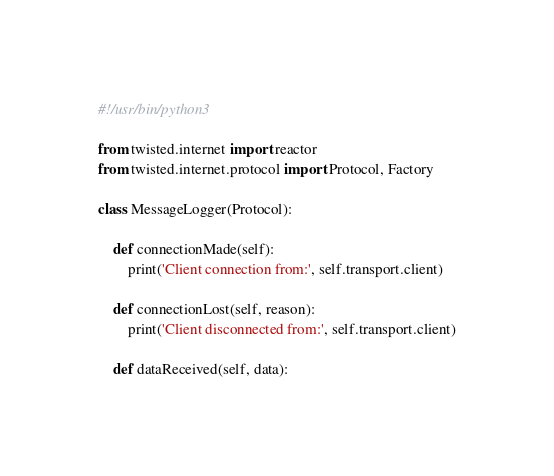Convert code to text. <code><loc_0><loc_0><loc_500><loc_500><_Python_>#!/usr/bin/python3

from twisted.internet import reactor
from twisted.internet.protocol import Protocol, Factory

class MessageLogger(Protocol):

	def connectionMade(self):
		print('Client connection from:', self.transport.client)
	
	def connectionLost(self, reason):
		print('Client disconnected from:', self.transport.client)
		
	def dataReceived(self, data):</code> 